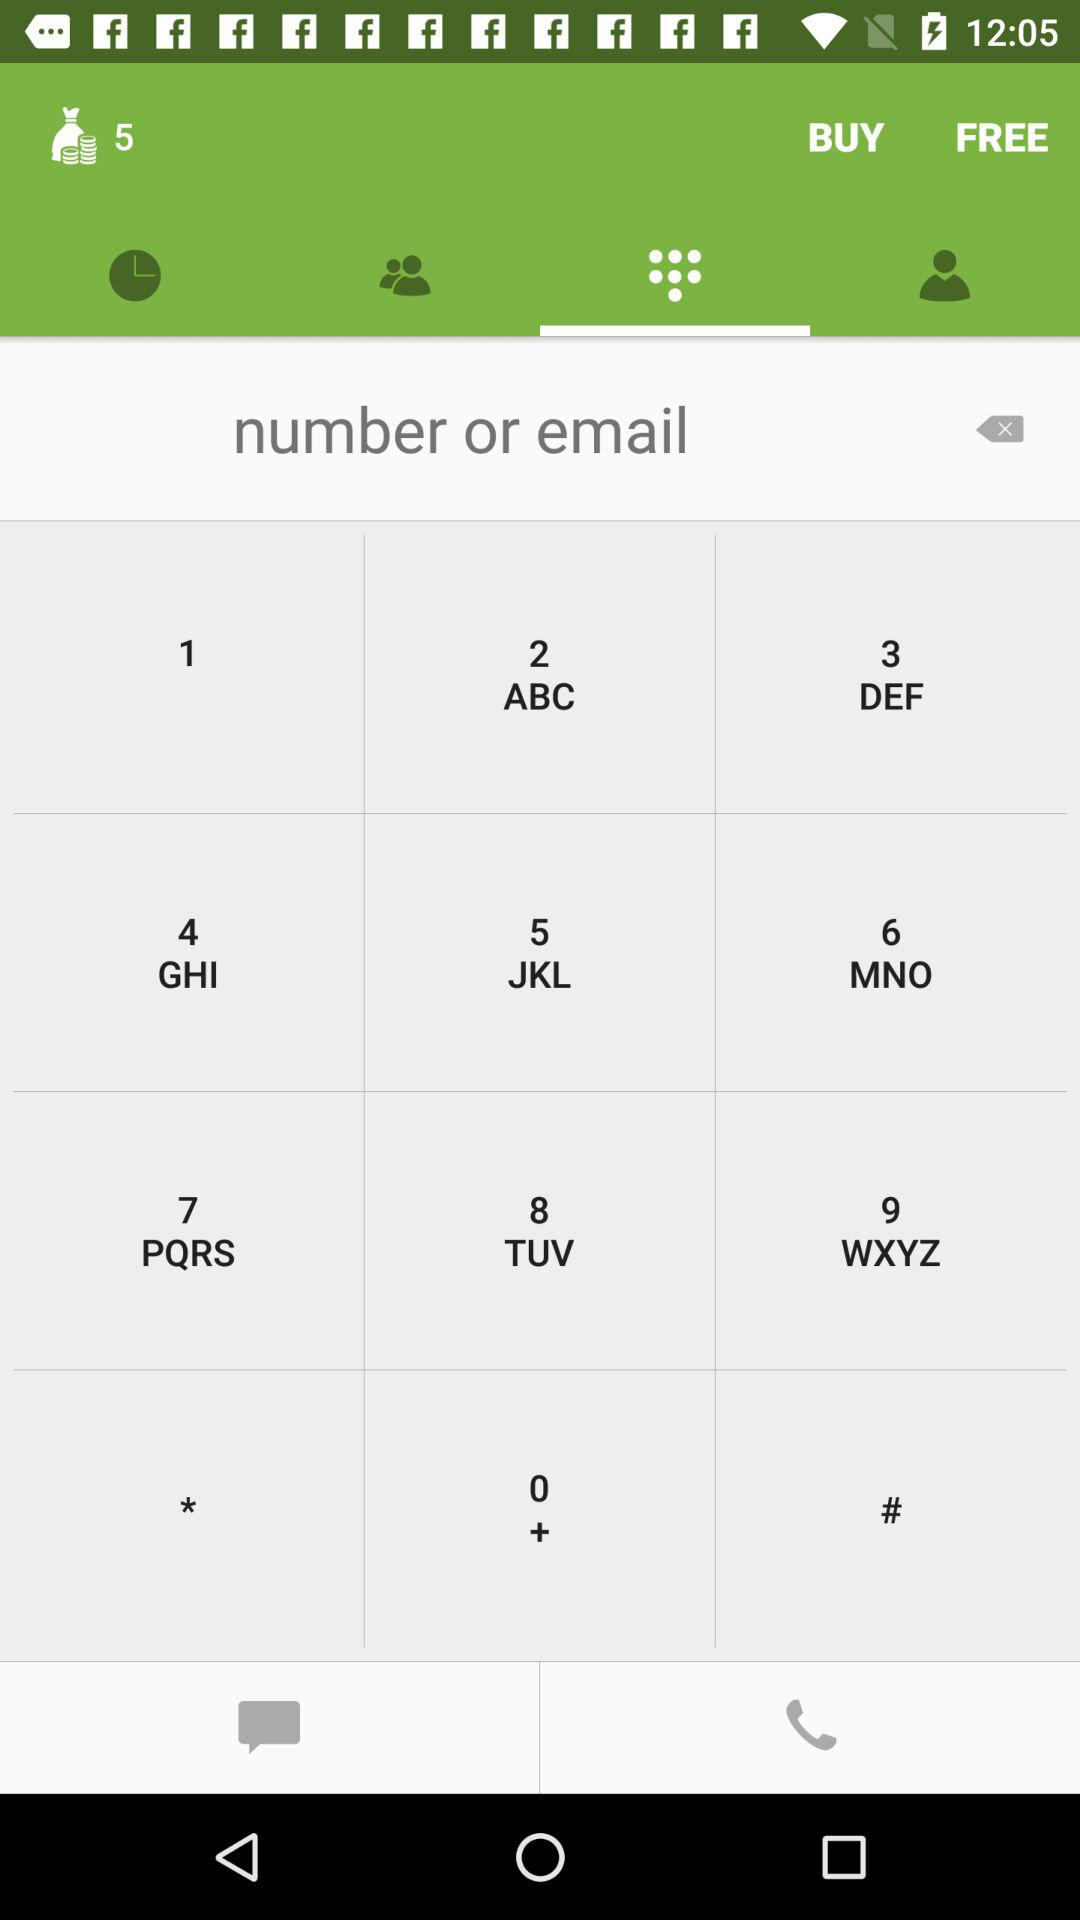What is the number of coins? The number of coins is 5. 